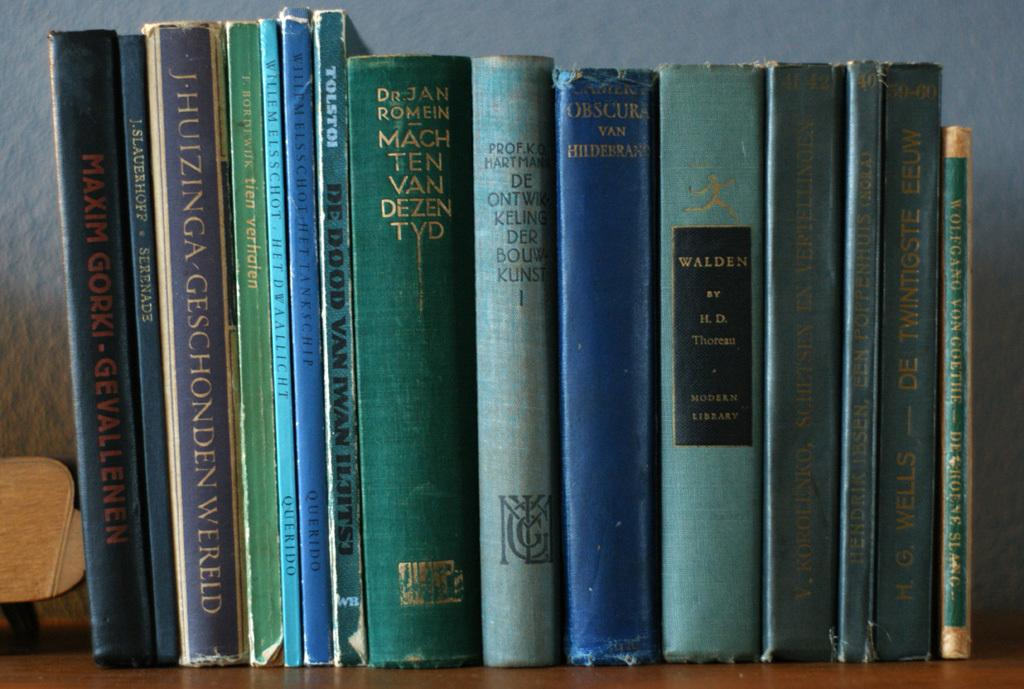<image>
Share a concise interpretation of the image provided. A stack of old books on a shelf, one of which has the word Walden on it. 